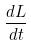<formula> <loc_0><loc_0><loc_500><loc_500>\frac { d L } { d t }</formula> 